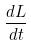<formula> <loc_0><loc_0><loc_500><loc_500>\frac { d L } { d t }</formula> 